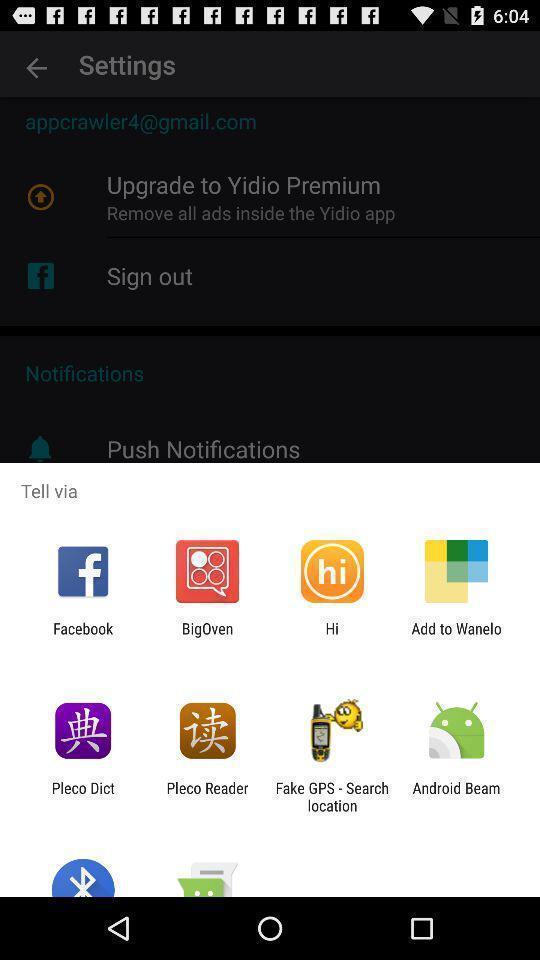Describe the visual elements of this screenshot. Pop-up showing different sharing options. 